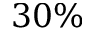<formula> <loc_0><loc_0><loc_500><loc_500>3 0 \%</formula> 